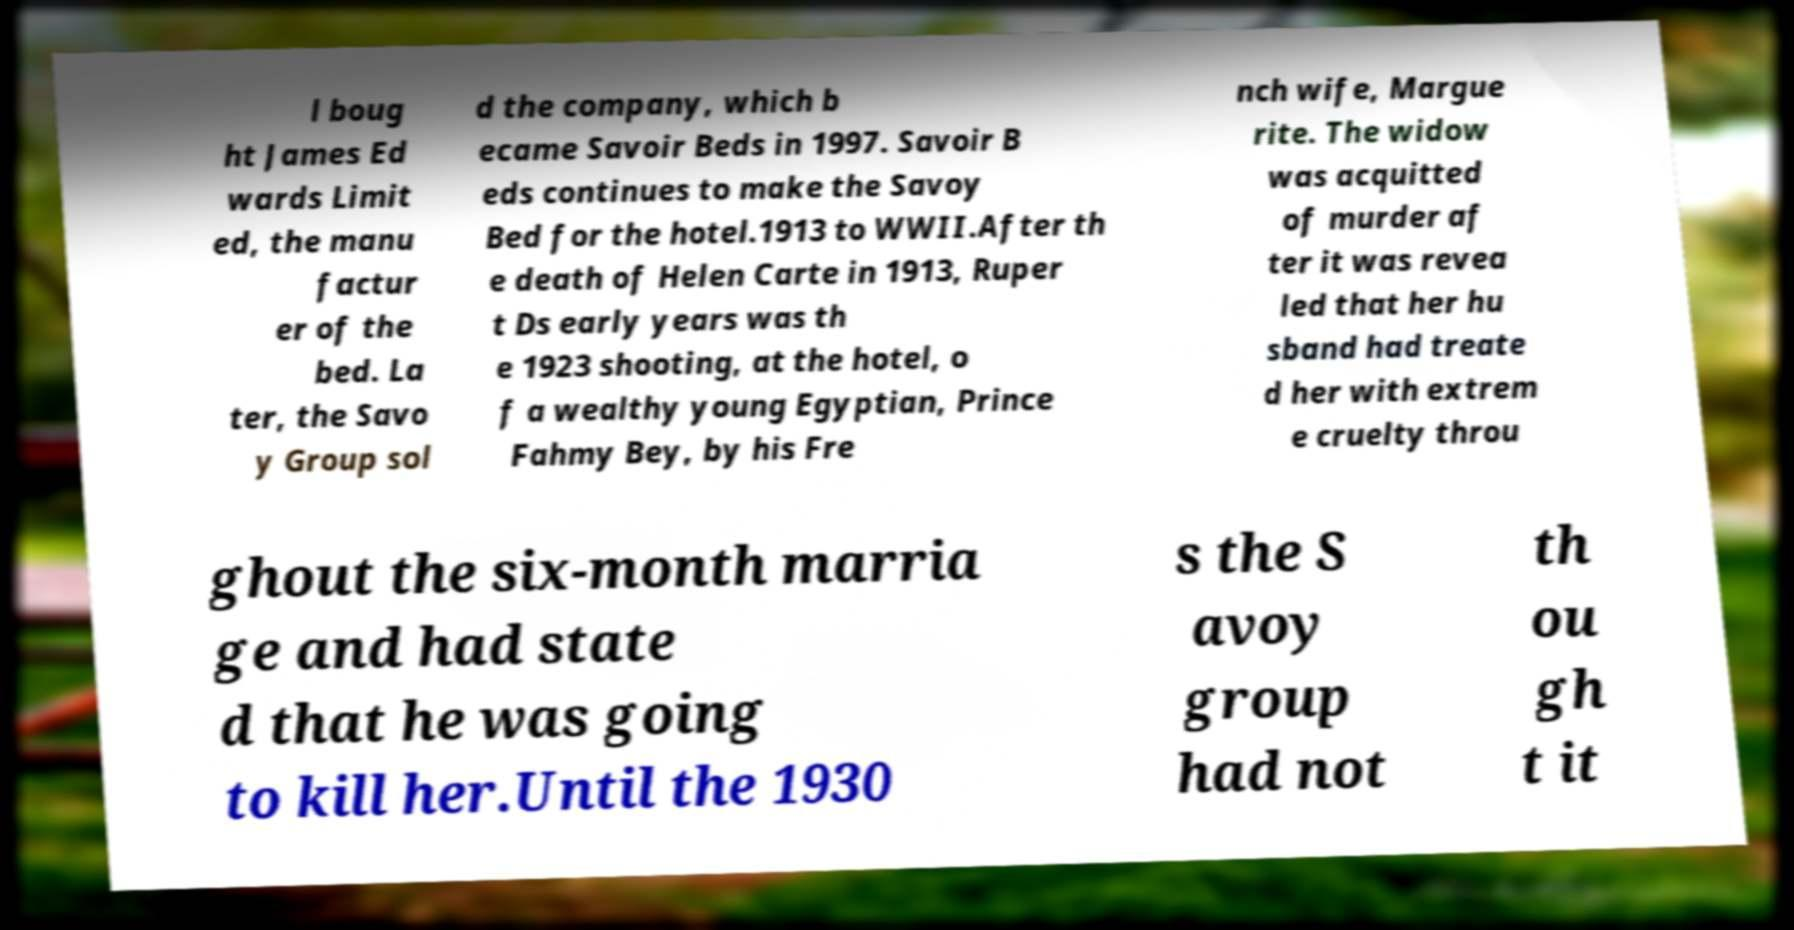Could you assist in decoding the text presented in this image and type it out clearly? l boug ht James Ed wards Limit ed, the manu factur er of the bed. La ter, the Savo y Group sol d the company, which b ecame Savoir Beds in 1997. Savoir B eds continues to make the Savoy Bed for the hotel.1913 to WWII.After th e death of Helen Carte in 1913, Ruper t Ds early years was th e 1923 shooting, at the hotel, o f a wealthy young Egyptian, Prince Fahmy Bey, by his Fre nch wife, Margue rite. The widow was acquitted of murder af ter it was revea led that her hu sband had treate d her with extrem e cruelty throu ghout the six-month marria ge and had state d that he was going to kill her.Until the 1930 s the S avoy group had not th ou gh t it 